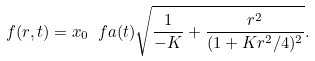Convert formula to latex. <formula><loc_0><loc_0><loc_500><loc_500>f ( r , t ) = x _ { 0 } \ f a ( t ) \sqrt { \frac { 1 } { - K } + \frac { r ^ { 2 } } { ( 1 + K r ^ { 2 } / 4 ) ^ { 2 } } } .</formula> 